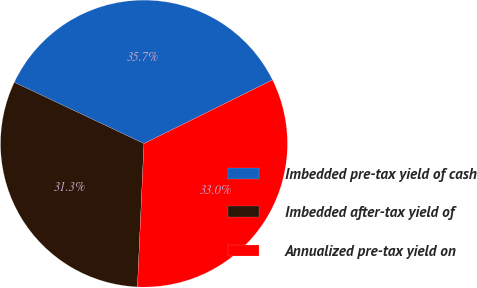Convert chart to OTSL. <chart><loc_0><loc_0><loc_500><loc_500><pie_chart><fcel>Imbedded pre-tax yield of cash<fcel>Imbedded after-tax yield of<fcel>Annualized pre-tax yield on<nl><fcel>35.65%<fcel>31.3%<fcel>33.04%<nl></chart> 